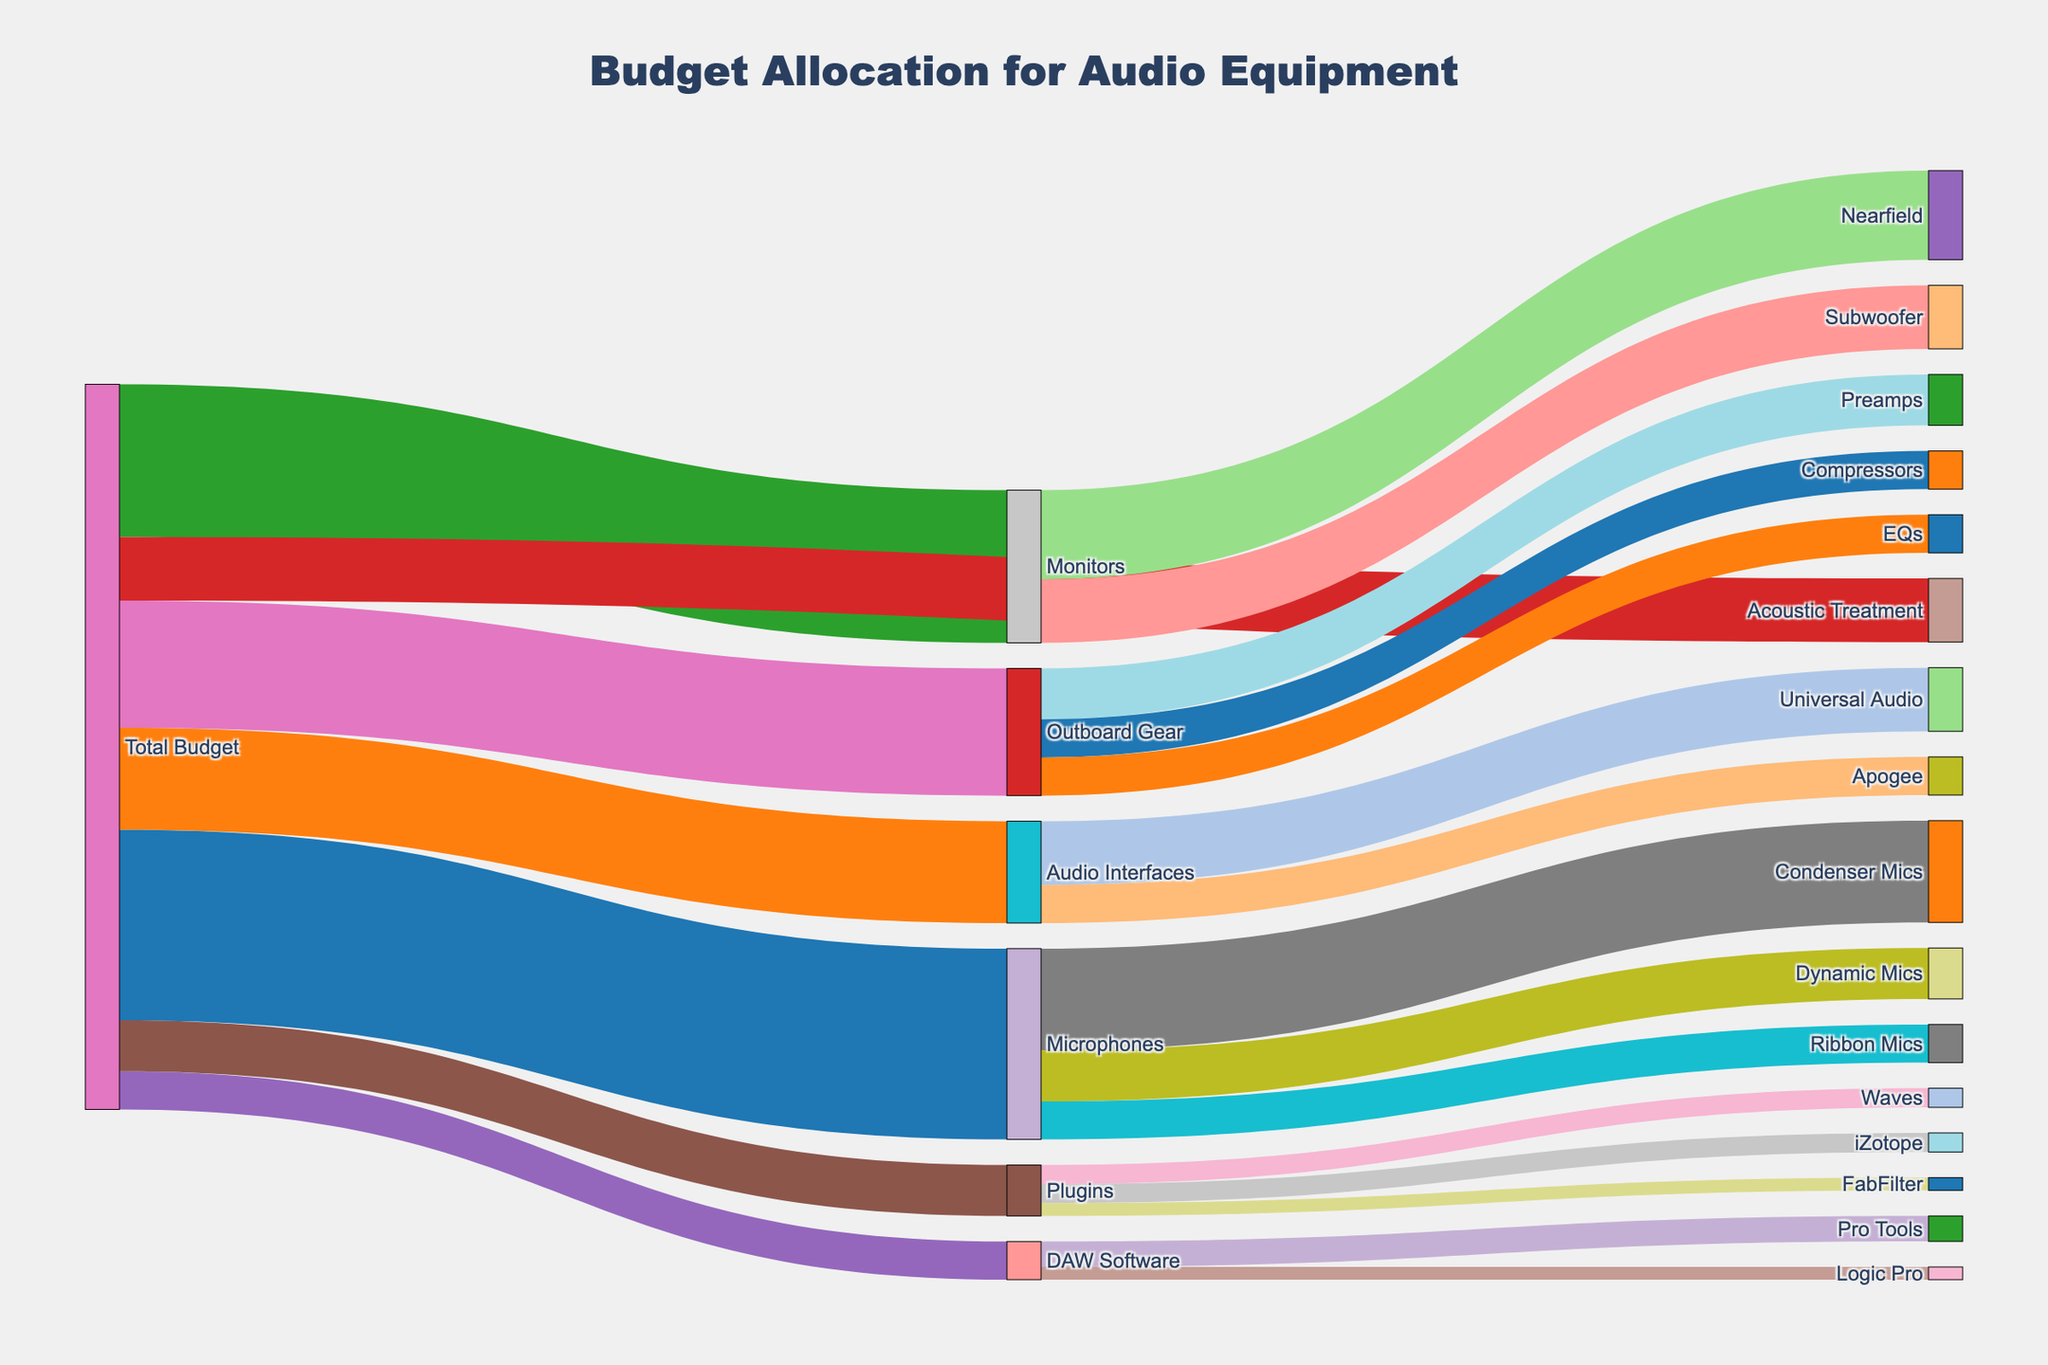How much of the total budget is allocated to Microphones? The total budget for Microphones is directly indicated in the figure under the "Microphones" node, connected by a link from the "Total Budget" node. Each link between nodes shows the allocated amount.
Answer: 15000 Which category under Microphones receives the highest funding? Within the "Microphones" category, there are three sub-categories: "Condenser Mics", "Dynamic Mics", and "Ribbon Mics". By comparing the values of links going to these sub-categories, "Condenser Mics" has the highest funding.
Answer: Condenser Mics What is the combined budget for Pro Tools and Logic Pro under DAW Software? The links under "DAW Software" show allocations to "Pro Tools" and "Logic Pro". Add these amounts to find the combined budget: 2000 (Pro Tools) + 1000 (Logic Pro) = 3000.
Answer: 3000 Which has a higher budget allocation: Outboard Gear or Audio Interfaces? By comparing the links from "Total Budget" to "Outboard Gear" and "Audio Interfaces", 10000 is allocated to Outboard Gear, and 8000 is allocated to Audio Interfaces. Thus, Outboard Gear has a higher budget allocation.
Answer: Outboard Gear What's the difference in budget allocation between Preamps and Compressors under Outboard Gear? Under the "Outboard Gear" node, Preamps have 4000 and Compressors have 3000. The difference is 4000 - 3000.
Answer: 1000 How much is spent on Plugins in total? Sum the budgets allocated to each sub-category under "Plugins": 1500 (Waves) + 1500 (iZotope) + 1000 (FabFilter).
Answer: 4000 Which category under Monitors has a larger allocation: Nearfield or Subwoofer? The "Monitors" node shows allocations to "Nearfield" and "Subwoofer". Comparing these values, 7000 (Nearfield) and 5000 (Subwoofer) indicates Nearfield has a larger allocation.
Answer: Nearfield What percentage of the total budget is allocated to Acoustic Treatment? The total budget is the sum of all initial allocations: 15000 + 8000 + 12000 + 5000 + 3000 + 4000 + 10000 = 57000. The allocation to Acoustic Treatment is 5000. The percentage is calculated as (5000 / 57000) * 100.
Answer: 8.77% What is the ratio of the budget allocated to Universal Audio interfaces versus Apogee interfaces? Universal Audio has 5000 and Apogee has 3000 allocated. The ratio is 5000:3000. Simplify this ratio by dividing both parts by their greatest common divisor, which is 1000.
Answer: 5:3 